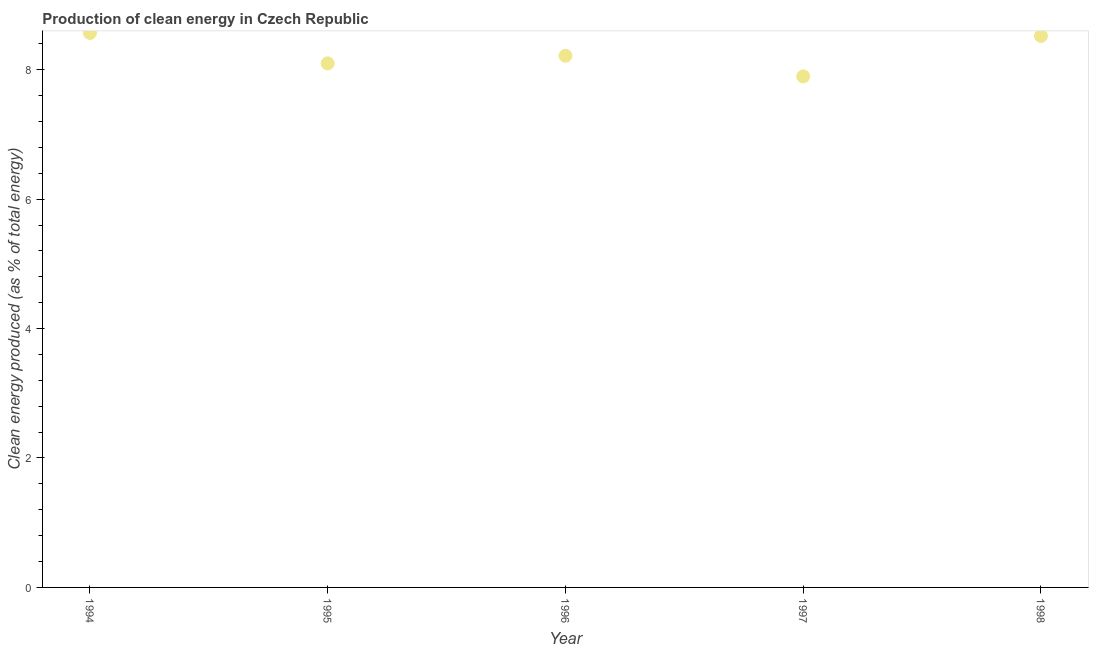What is the production of clean energy in 1998?
Give a very brief answer. 8.52. Across all years, what is the maximum production of clean energy?
Offer a terse response. 8.57. Across all years, what is the minimum production of clean energy?
Your answer should be very brief. 7.9. In which year was the production of clean energy maximum?
Make the answer very short. 1994. In which year was the production of clean energy minimum?
Provide a succinct answer. 1997. What is the sum of the production of clean energy?
Keep it short and to the point. 41.3. What is the difference between the production of clean energy in 1994 and 1996?
Provide a succinct answer. 0.35. What is the average production of clean energy per year?
Offer a very short reply. 8.26. What is the median production of clean energy?
Your answer should be compact. 8.22. What is the ratio of the production of clean energy in 1995 to that in 1997?
Offer a terse response. 1.03. Is the difference between the production of clean energy in 1994 and 1995 greater than the difference between any two years?
Your response must be concise. No. What is the difference between the highest and the second highest production of clean energy?
Provide a succinct answer. 0.05. What is the difference between the highest and the lowest production of clean energy?
Offer a very short reply. 0.67. How many dotlines are there?
Make the answer very short. 1. Are the values on the major ticks of Y-axis written in scientific E-notation?
Offer a very short reply. No. Does the graph contain any zero values?
Your response must be concise. No. What is the title of the graph?
Your response must be concise. Production of clean energy in Czech Republic. What is the label or title of the X-axis?
Offer a terse response. Year. What is the label or title of the Y-axis?
Your answer should be compact. Clean energy produced (as % of total energy). What is the Clean energy produced (as % of total energy) in 1994?
Keep it short and to the point. 8.57. What is the Clean energy produced (as % of total energy) in 1995?
Ensure brevity in your answer.  8.1. What is the Clean energy produced (as % of total energy) in 1996?
Your response must be concise. 8.22. What is the Clean energy produced (as % of total energy) in 1997?
Your answer should be very brief. 7.9. What is the Clean energy produced (as % of total energy) in 1998?
Make the answer very short. 8.52. What is the difference between the Clean energy produced (as % of total energy) in 1994 and 1995?
Give a very brief answer. 0.47. What is the difference between the Clean energy produced (as % of total energy) in 1994 and 1996?
Provide a short and direct response. 0.35. What is the difference between the Clean energy produced (as % of total energy) in 1994 and 1997?
Keep it short and to the point. 0.67. What is the difference between the Clean energy produced (as % of total energy) in 1994 and 1998?
Your answer should be very brief. 0.05. What is the difference between the Clean energy produced (as % of total energy) in 1995 and 1996?
Your answer should be compact. -0.12. What is the difference between the Clean energy produced (as % of total energy) in 1995 and 1997?
Ensure brevity in your answer.  0.2. What is the difference between the Clean energy produced (as % of total energy) in 1995 and 1998?
Offer a terse response. -0.42. What is the difference between the Clean energy produced (as % of total energy) in 1996 and 1997?
Offer a terse response. 0.32. What is the difference between the Clean energy produced (as % of total energy) in 1996 and 1998?
Your answer should be compact. -0.31. What is the difference between the Clean energy produced (as % of total energy) in 1997 and 1998?
Ensure brevity in your answer.  -0.63. What is the ratio of the Clean energy produced (as % of total energy) in 1994 to that in 1995?
Provide a succinct answer. 1.06. What is the ratio of the Clean energy produced (as % of total energy) in 1994 to that in 1996?
Offer a terse response. 1.04. What is the ratio of the Clean energy produced (as % of total energy) in 1994 to that in 1997?
Ensure brevity in your answer.  1.08. What is the ratio of the Clean energy produced (as % of total energy) in 1994 to that in 1998?
Offer a very short reply. 1. What is the ratio of the Clean energy produced (as % of total energy) in 1995 to that in 1996?
Give a very brief answer. 0.99. What is the ratio of the Clean energy produced (as % of total energy) in 1995 to that in 1997?
Offer a very short reply. 1.03. What is the ratio of the Clean energy produced (as % of total energy) in 1995 to that in 1998?
Your answer should be compact. 0.95. What is the ratio of the Clean energy produced (as % of total energy) in 1996 to that in 1997?
Your answer should be compact. 1.04. What is the ratio of the Clean energy produced (as % of total energy) in 1996 to that in 1998?
Provide a succinct answer. 0.96. What is the ratio of the Clean energy produced (as % of total energy) in 1997 to that in 1998?
Offer a terse response. 0.93. 